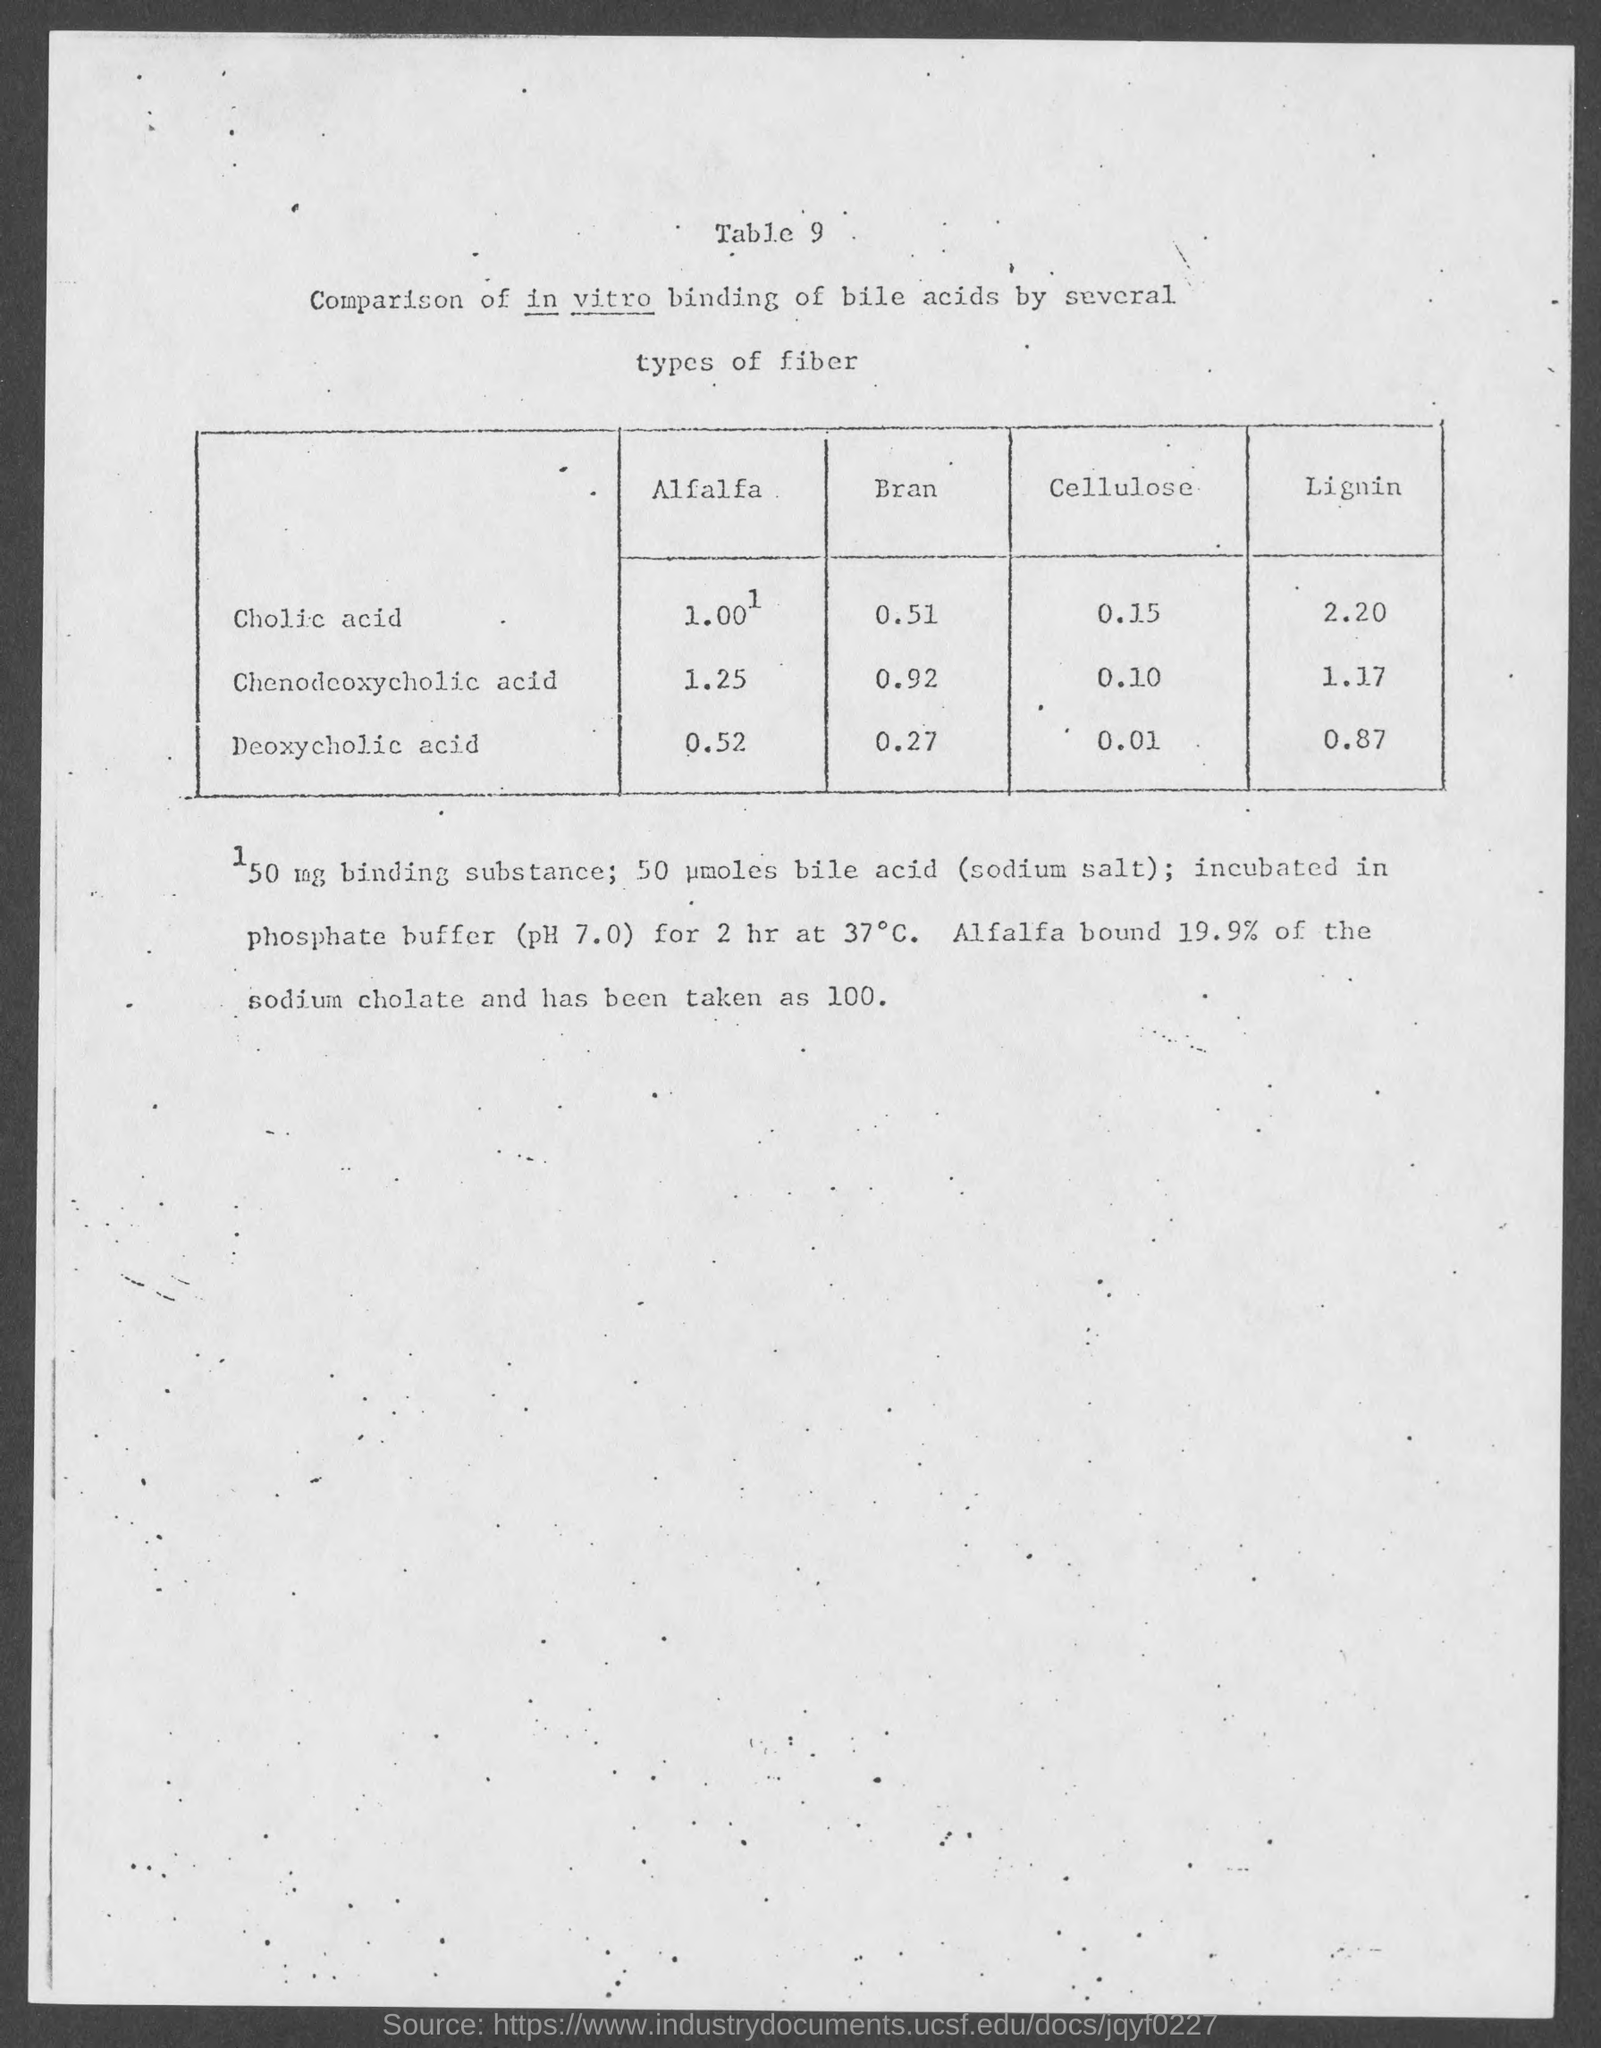Indicate a few pertinent items in this graphic. The amount of lignin present in chenodeoxycholic acid is 1.17. What table number is mentioned? It is the 9th table. 